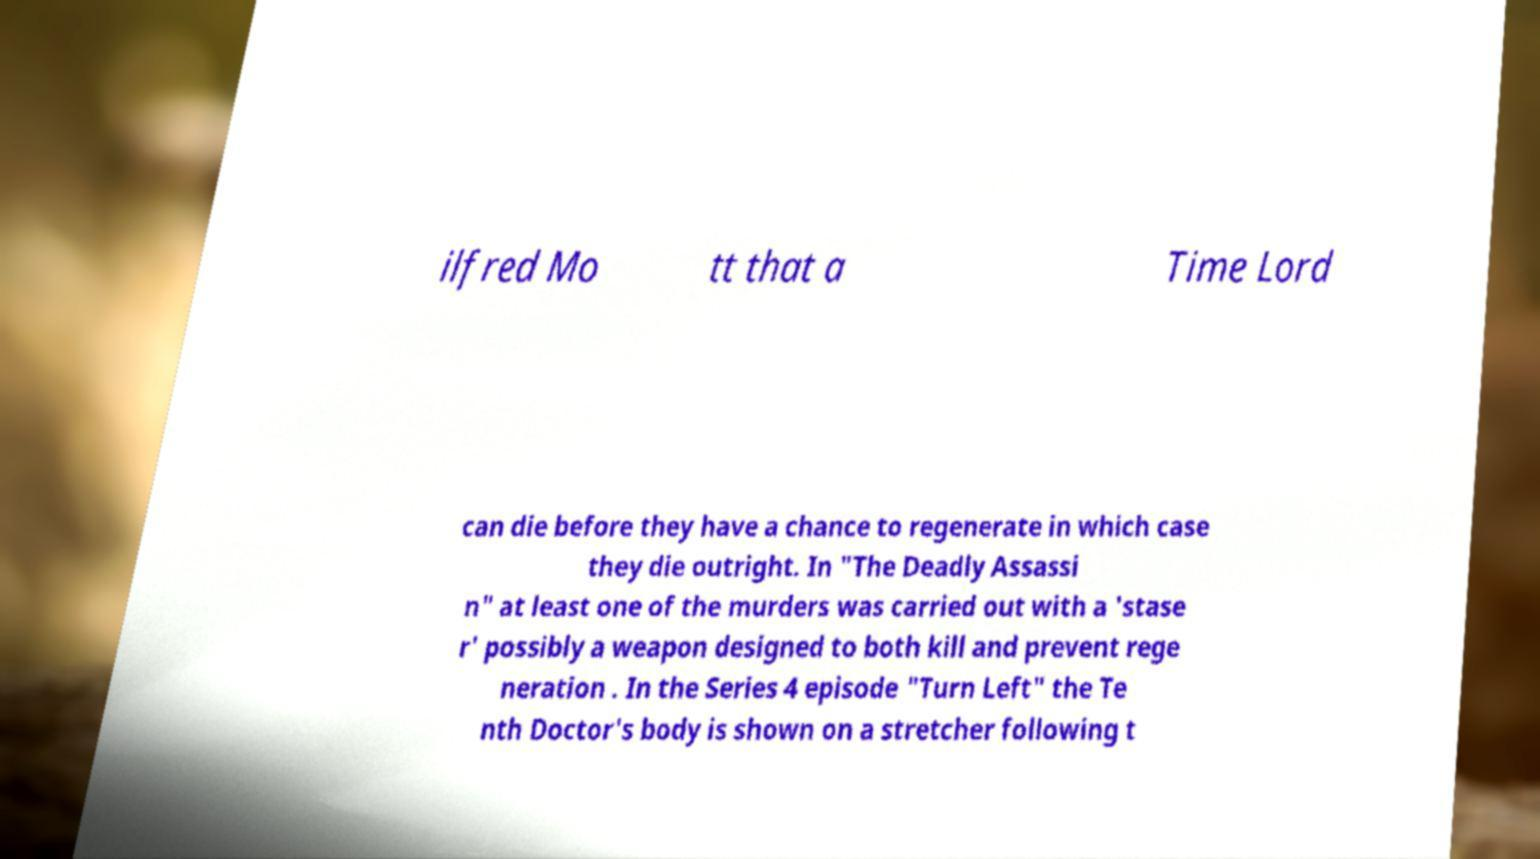Can you read and provide the text displayed in the image?This photo seems to have some interesting text. Can you extract and type it out for me? ilfred Mo tt that a Time Lord can die before they have a chance to regenerate in which case they die outright. In "The Deadly Assassi n" at least one of the murders was carried out with a 'stase r' possibly a weapon designed to both kill and prevent rege neration . In the Series 4 episode "Turn Left" the Te nth Doctor's body is shown on a stretcher following t 